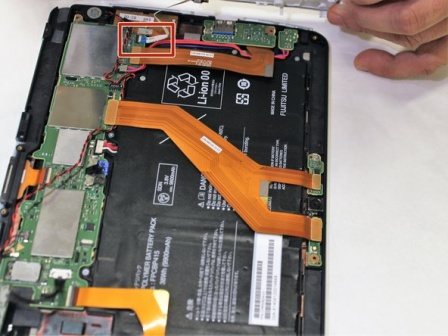Can you explain the role of the cables we see in the tablet? Certainly! The orange and red cables inside the tablet are flexible flat cables. They are crucial for connecting various components, such as the screen, battery, and circuit boards. These cables transmit data and power between components, allowing the tablet to function smoothly as a unified device. 